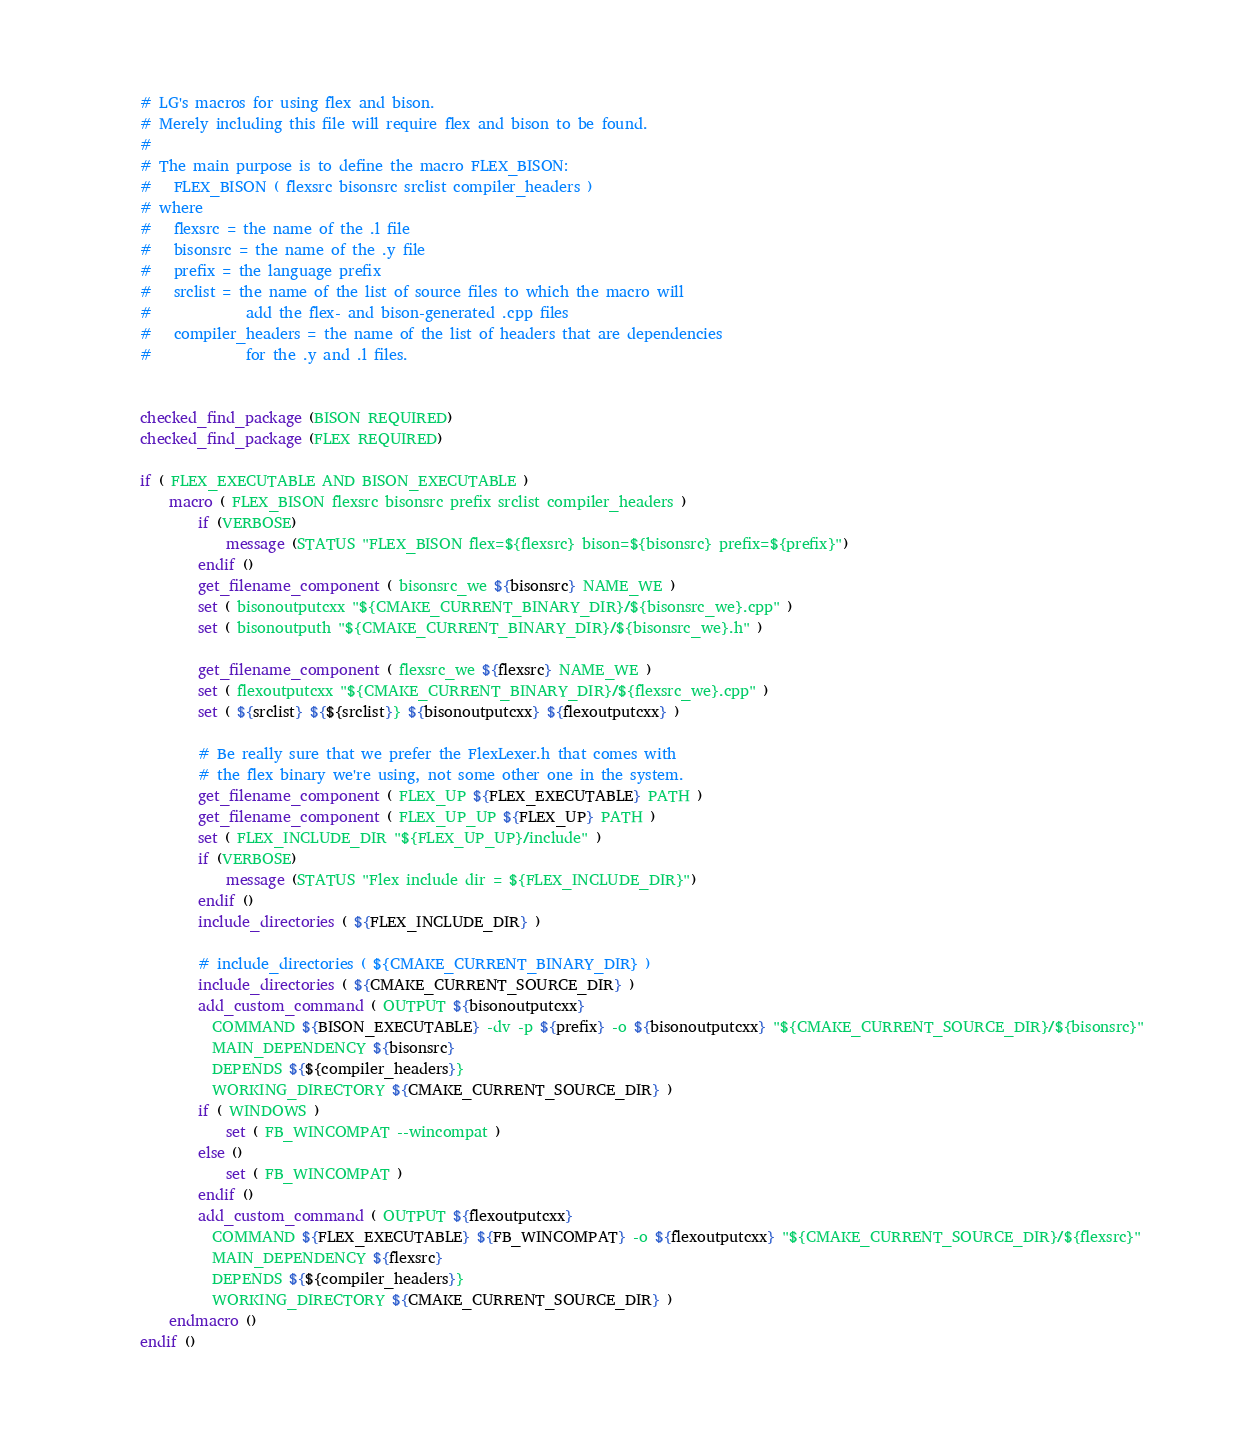<code> <loc_0><loc_0><loc_500><loc_500><_CMake_># LG's macros for using flex and bison.
# Merely including this file will require flex and bison to be found.
#
# The main purpose is to define the macro FLEX_BISON:
#   FLEX_BISON ( flexsrc bisonsrc srclist compiler_headers )
# where
#   flexsrc = the name of the .l file
#   bisonsrc = the name of the .y file
#   prefix = the language prefix
#   srclist = the name of the list of source files to which the macro will
#             add the flex- and bison-generated .cpp files
#   compiler_headers = the name of the list of headers that are dependencies
#             for the .y and .l files.


checked_find_package (BISON REQUIRED)
checked_find_package (FLEX REQUIRED)

if ( FLEX_EXECUTABLE AND BISON_EXECUTABLE )
    macro ( FLEX_BISON flexsrc bisonsrc prefix srclist compiler_headers )
        if (VERBOSE)
            message (STATUS "FLEX_BISON flex=${flexsrc} bison=${bisonsrc} prefix=${prefix}")
        endif ()
        get_filename_component ( bisonsrc_we ${bisonsrc} NAME_WE )
        set ( bisonoutputcxx "${CMAKE_CURRENT_BINARY_DIR}/${bisonsrc_we}.cpp" )
        set ( bisonoutputh "${CMAKE_CURRENT_BINARY_DIR}/${bisonsrc_we}.h" )

        get_filename_component ( flexsrc_we ${flexsrc} NAME_WE )
        set ( flexoutputcxx "${CMAKE_CURRENT_BINARY_DIR}/${flexsrc_we}.cpp" )
        set ( ${srclist} ${${srclist}} ${bisonoutputcxx} ${flexoutputcxx} )

        # Be really sure that we prefer the FlexLexer.h that comes with
        # the flex binary we're using, not some other one in the system.
        get_filename_component ( FLEX_UP ${FLEX_EXECUTABLE} PATH )
        get_filename_component ( FLEX_UP_UP ${FLEX_UP} PATH )
        set ( FLEX_INCLUDE_DIR "${FLEX_UP_UP}/include" )
        if (VERBOSE)
            message (STATUS "Flex include dir = ${FLEX_INCLUDE_DIR}")
        endif ()
        include_directories ( ${FLEX_INCLUDE_DIR} )

        # include_directories ( ${CMAKE_CURRENT_BINARY_DIR} )
        include_directories ( ${CMAKE_CURRENT_SOURCE_DIR} )
        add_custom_command ( OUTPUT ${bisonoutputcxx}
          COMMAND ${BISON_EXECUTABLE} -dv -p ${prefix} -o ${bisonoutputcxx} "${CMAKE_CURRENT_SOURCE_DIR}/${bisonsrc}"
          MAIN_DEPENDENCY ${bisonsrc}
          DEPENDS ${${compiler_headers}}
          WORKING_DIRECTORY ${CMAKE_CURRENT_SOURCE_DIR} )
        if ( WINDOWS )
            set ( FB_WINCOMPAT --wincompat )
        else ()
            set ( FB_WINCOMPAT )
        endif ()
        add_custom_command ( OUTPUT ${flexoutputcxx}
          COMMAND ${FLEX_EXECUTABLE} ${FB_WINCOMPAT} -o ${flexoutputcxx} "${CMAKE_CURRENT_SOURCE_DIR}/${flexsrc}"
          MAIN_DEPENDENCY ${flexsrc}
          DEPENDS ${${compiler_headers}}
          WORKING_DIRECTORY ${CMAKE_CURRENT_SOURCE_DIR} )
    endmacro ()
endif ()
</code> 